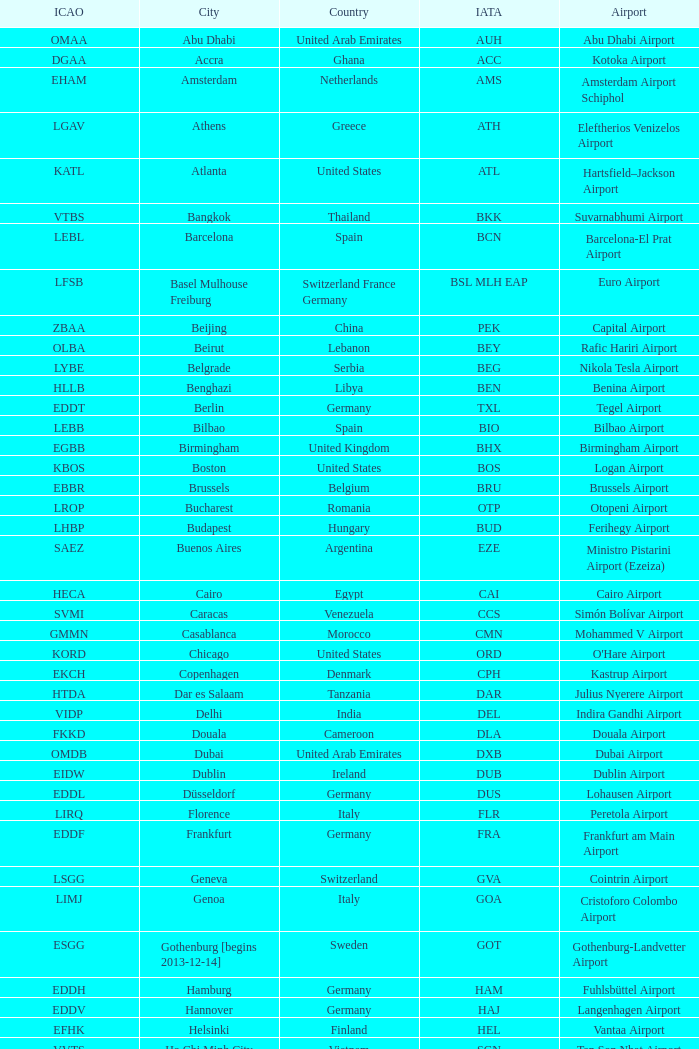What city is fuhlsbüttel airport in? Hamburg. 